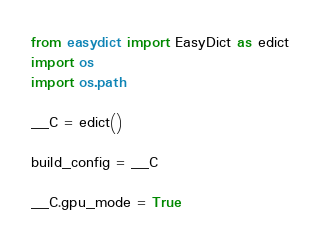Convert code to text. <code><loc_0><loc_0><loc_500><loc_500><_Python_>from easydict import EasyDict as edict
import os
import os.path

__C = edict()

build_config = __C

__C.gpu_mode = True
</code> 